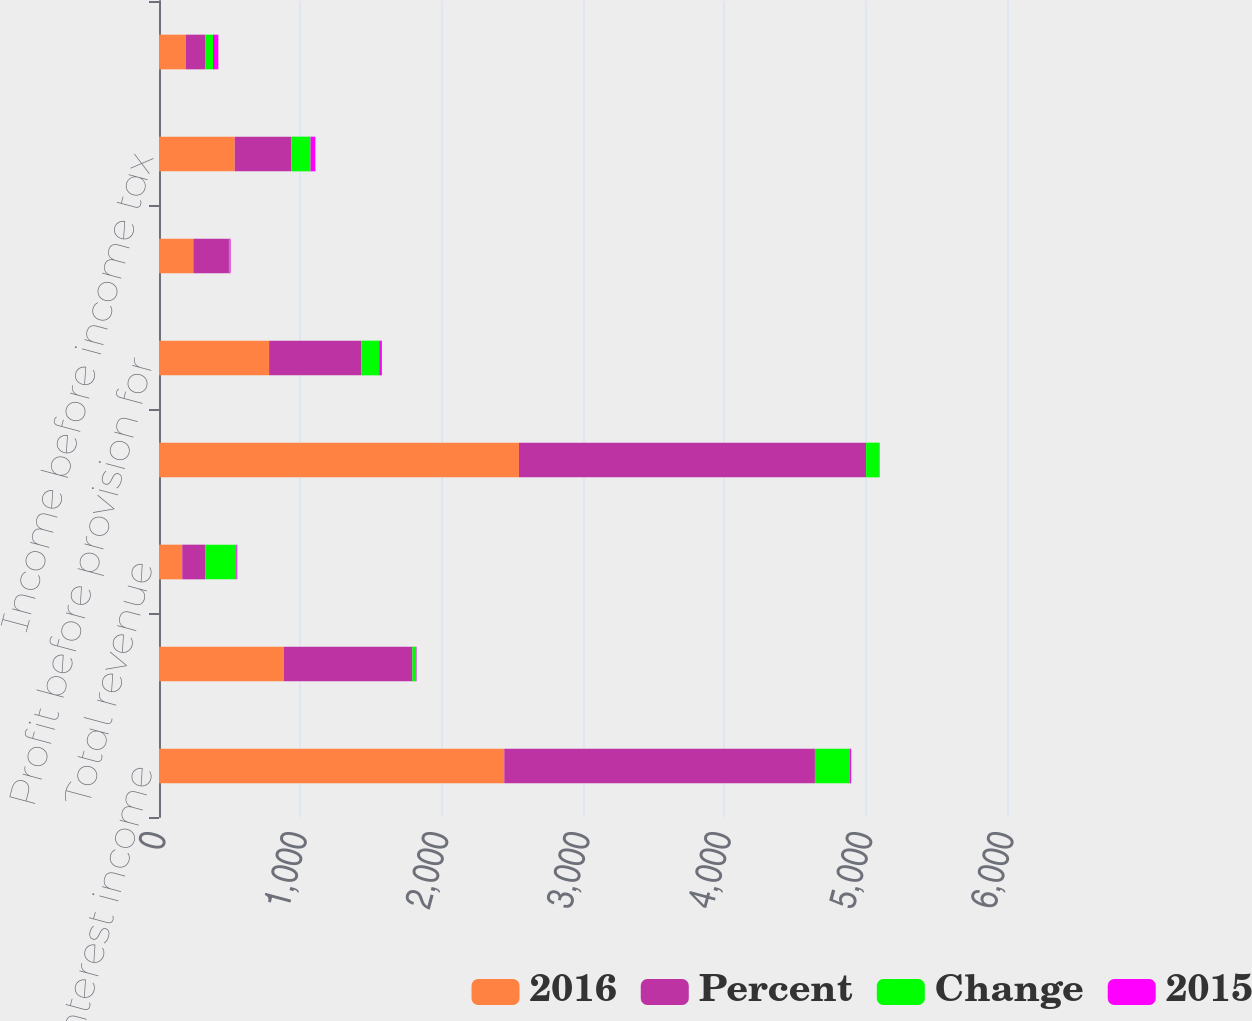<chart> <loc_0><loc_0><loc_500><loc_500><stacked_bar_chart><ecel><fcel>Net interest income<fcel>Noninterest income<fcel>Total revenue<fcel>Noninterest expense<fcel>Profit before provision for<fcel>Provision for credit losses<fcel>Income before income tax<fcel>Income tax expense<nl><fcel>2016<fcel>2443<fcel>883<fcel>164.5<fcel>2547<fcel>779<fcel>243<fcel>536<fcel>191<nl><fcel>Percent<fcel>2198<fcel>910<fcel>164.5<fcel>2456<fcel>652<fcel>252<fcel>400<fcel>138<nl><fcel>Change<fcel>245<fcel>27<fcel>218<fcel>91<fcel>127<fcel>9<fcel>136<fcel>53<nl><fcel>2015<fcel>11<fcel>3<fcel>7<fcel>4<fcel>19<fcel>4<fcel>34<fcel>38<nl></chart> 